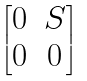<formula> <loc_0><loc_0><loc_500><loc_500>\begin{bmatrix} 0 & S \\ 0 & 0 \end{bmatrix}</formula> 